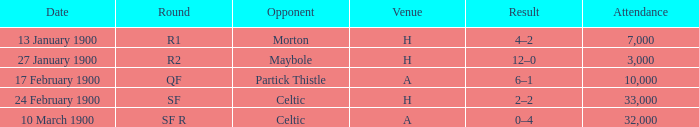What was the attendance count for the game versus morton? 7000.0. 